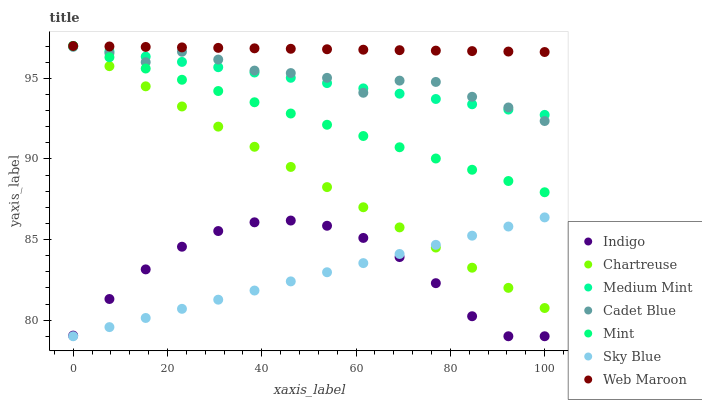Does Sky Blue have the minimum area under the curve?
Answer yes or no. Yes. Does Web Maroon have the maximum area under the curve?
Answer yes or no. Yes. Does Cadet Blue have the minimum area under the curve?
Answer yes or no. No. Does Cadet Blue have the maximum area under the curve?
Answer yes or no. No. Is Web Maroon the smoothest?
Answer yes or no. Yes. Is Cadet Blue the roughest?
Answer yes or no. Yes. Is Indigo the smoothest?
Answer yes or no. No. Is Indigo the roughest?
Answer yes or no. No. Does Indigo have the lowest value?
Answer yes or no. Yes. Does Cadet Blue have the lowest value?
Answer yes or no. No. Does Mint have the highest value?
Answer yes or no. Yes. Does Cadet Blue have the highest value?
Answer yes or no. No. Is Cadet Blue less than Web Maroon?
Answer yes or no. Yes. Is Cadet Blue greater than Indigo?
Answer yes or no. Yes. Does Sky Blue intersect Indigo?
Answer yes or no. Yes. Is Sky Blue less than Indigo?
Answer yes or no. No. Is Sky Blue greater than Indigo?
Answer yes or no. No. Does Cadet Blue intersect Web Maroon?
Answer yes or no. No. 